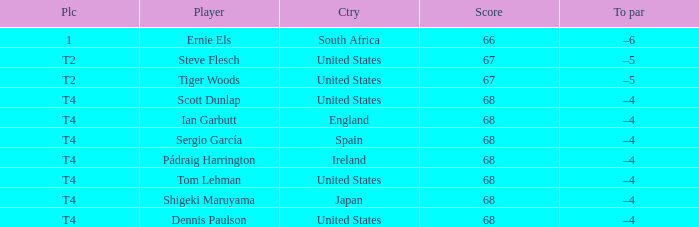What is the Place of the Player with a Score of 67? T2, T2. 